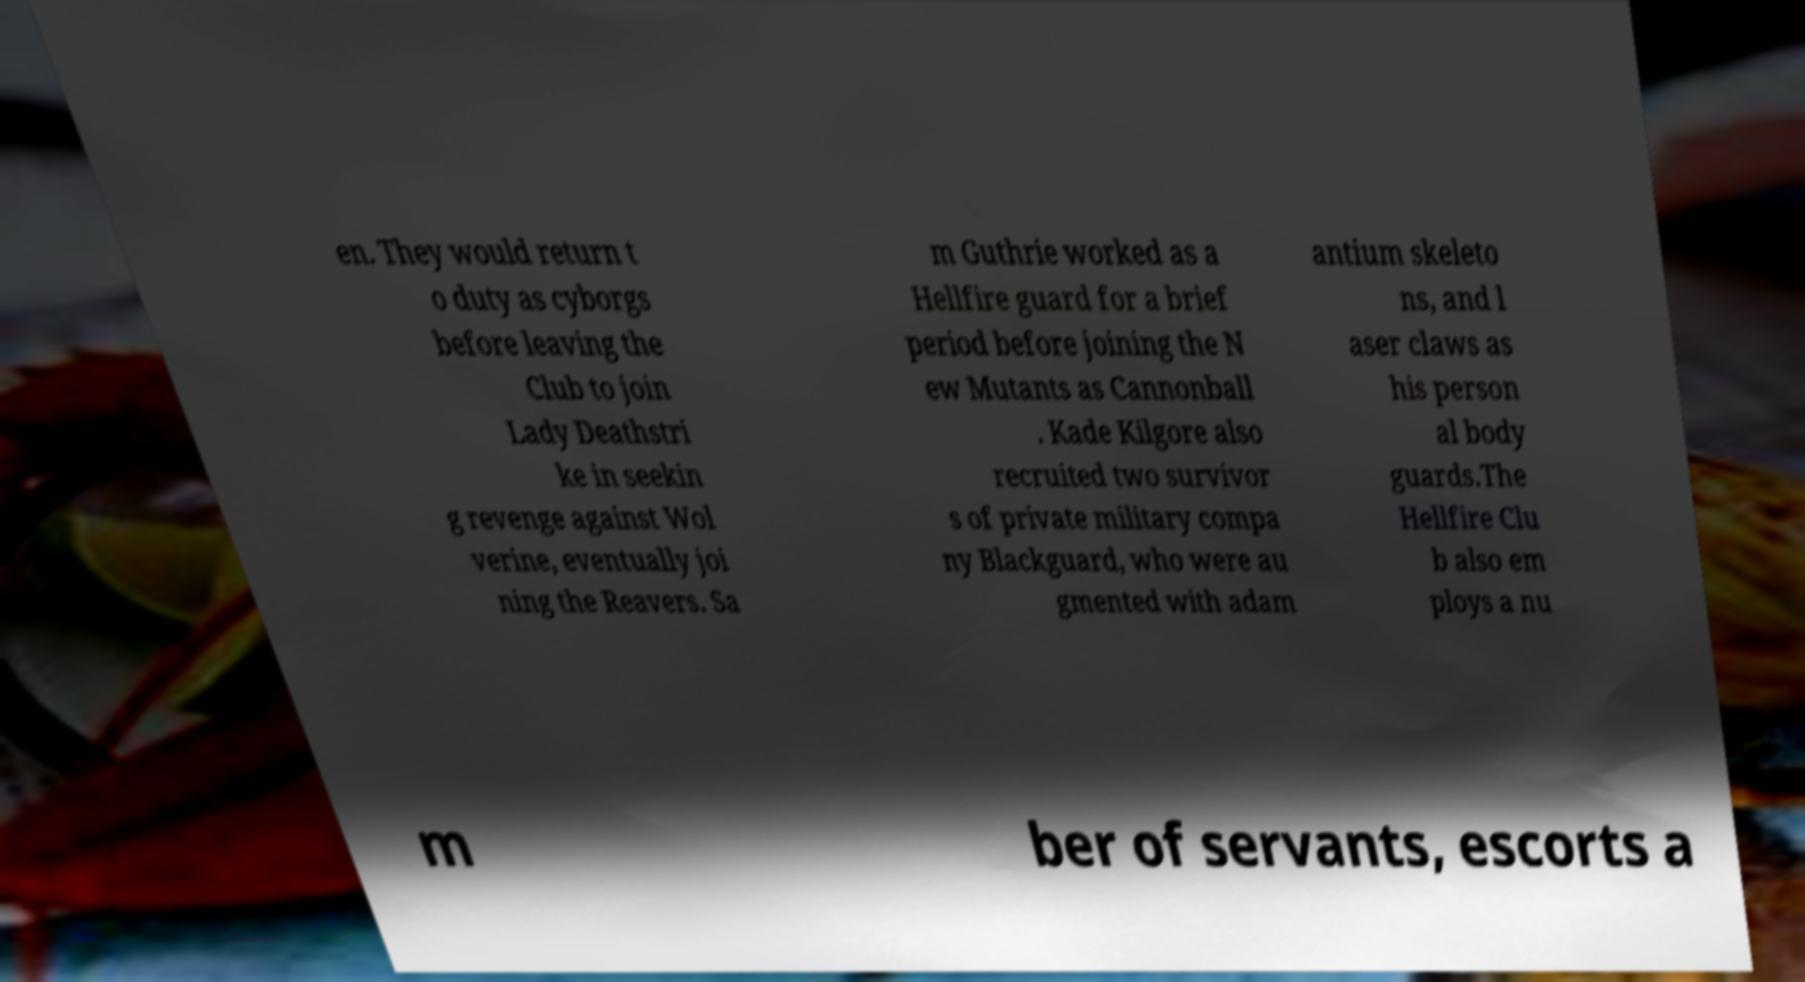What messages or text are displayed in this image? I need them in a readable, typed format. en. They would return t o duty as cyborgs before leaving the Club to join Lady Deathstri ke in seekin g revenge against Wol verine, eventually joi ning the Reavers. Sa m Guthrie worked as a Hellfire guard for a brief period before joining the N ew Mutants as Cannonball . Kade Kilgore also recruited two survivor s of private military compa ny Blackguard, who were au gmented with adam antium skeleto ns, and l aser claws as his person al body guards.The Hellfire Clu b also em ploys a nu m ber of servants, escorts a 